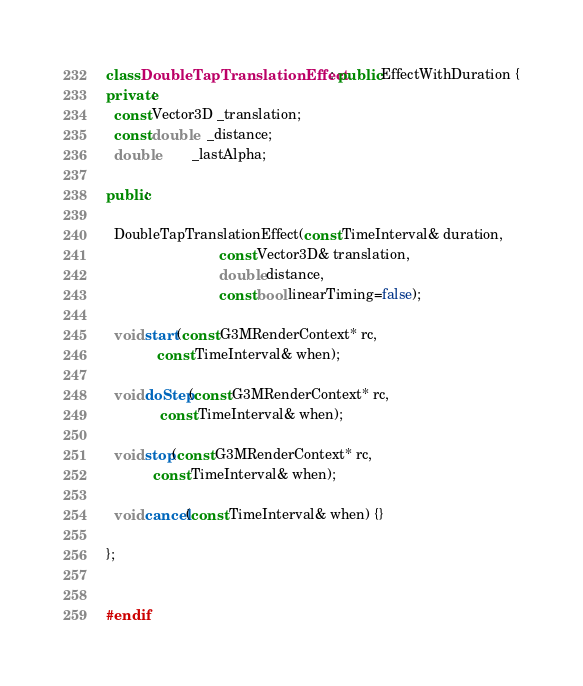<code> <loc_0><loc_0><loc_500><loc_500><_C++_>
class DoubleTapTranslationEffect : public EffectWithDuration {
private:
  const Vector3D _translation;
  const double   _distance;
  double         _lastAlpha;

public:

  DoubleTapTranslationEffect(const TimeInterval& duration,
                             const Vector3D& translation,
                             double distance,
                             const bool linearTiming=false);

  void start(const G3MRenderContext* rc,
             const TimeInterval& when);

  void doStep(const G3MRenderContext* rc,
              const TimeInterval& when);

  void stop(const G3MRenderContext* rc,
            const TimeInterval& when);

  void cancel(const TimeInterval& when) {}
  
};


#endif
</code> 